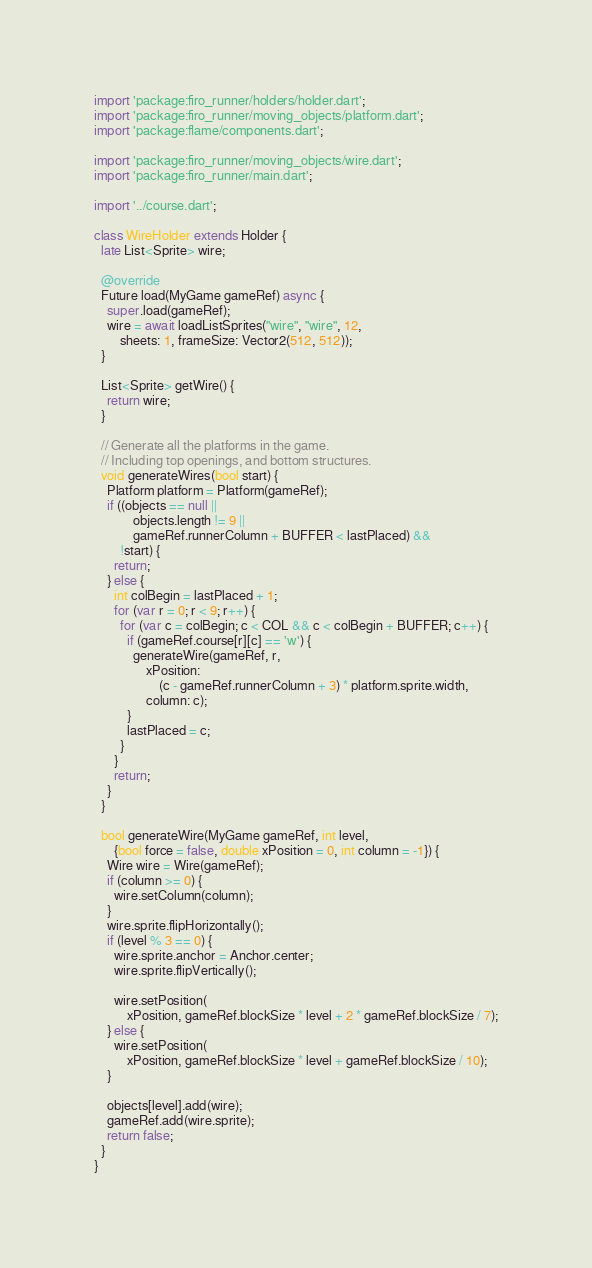Convert code to text. <code><loc_0><loc_0><loc_500><loc_500><_Dart_>import 'package:firo_runner/holders/holder.dart';
import 'package:firo_runner/moving_objects/platform.dart';
import 'package:flame/components.dart';

import 'package:firo_runner/moving_objects/wire.dart';
import 'package:firo_runner/main.dart';

import '../course.dart';

class WireHolder extends Holder {
  late List<Sprite> wire;

  @override
  Future load(MyGame gameRef) async {
    super.load(gameRef);
    wire = await loadListSprites("wire", "wire", 12,
        sheets: 1, frameSize: Vector2(512, 512));
  }

  List<Sprite> getWire() {
    return wire;
  }

  // Generate all the platforms in the game.
  // Including top openings, and bottom structures.
  void generateWires(bool start) {
    Platform platform = Platform(gameRef);
    if ((objects == null ||
            objects.length != 9 ||
            gameRef.runnerColumn + BUFFER < lastPlaced) &&
        !start) {
      return;
    } else {
      int colBegin = lastPlaced + 1;
      for (var r = 0; r < 9; r++) {
        for (var c = colBegin; c < COL && c < colBegin + BUFFER; c++) {
          if (gameRef.course[r][c] == 'w') {
            generateWire(gameRef, r,
                xPosition:
                    (c - gameRef.runnerColumn + 3) * platform.sprite.width,
                column: c);
          }
          lastPlaced = c;
        }
      }
      return;
    }
  }

  bool generateWire(MyGame gameRef, int level,
      {bool force = false, double xPosition = 0, int column = -1}) {
    Wire wire = Wire(gameRef);
    if (column >= 0) {
      wire.setColumn(column);
    }
    wire.sprite.flipHorizontally();
    if (level % 3 == 0) {
      wire.sprite.anchor = Anchor.center;
      wire.sprite.flipVertically();

      wire.setPosition(
          xPosition, gameRef.blockSize * level + 2 * gameRef.blockSize / 7);
    } else {
      wire.setPosition(
          xPosition, gameRef.blockSize * level + gameRef.blockSize / 10);
    }

    objects[level].add(wire);
    gameRef.add(wire.sprite);
    return false;
  }
}
</code> 